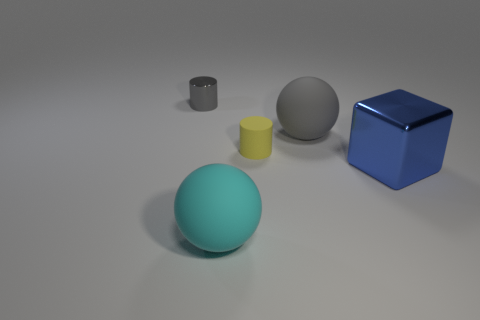Add 5 cyan things. How many objects exist? 10 Subtract all spheres. How many objects are left? 3 Subtract 0 yellow balls. How many objects are left? 5 Subtract all small gray metal objects. Subtract all large metallic cubes. How many objects are left? 3 Add 3 tiny gray metal things. How many tiny gray metal things are left? 4 Add 2 purple metal cubes. How many purple metal cubes exist? 2 